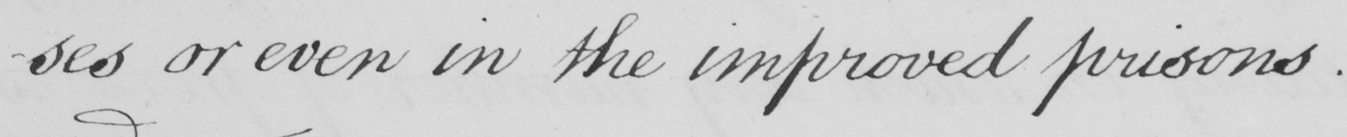What text is written in this handwritten line? -ses or even in the improved prisons. 